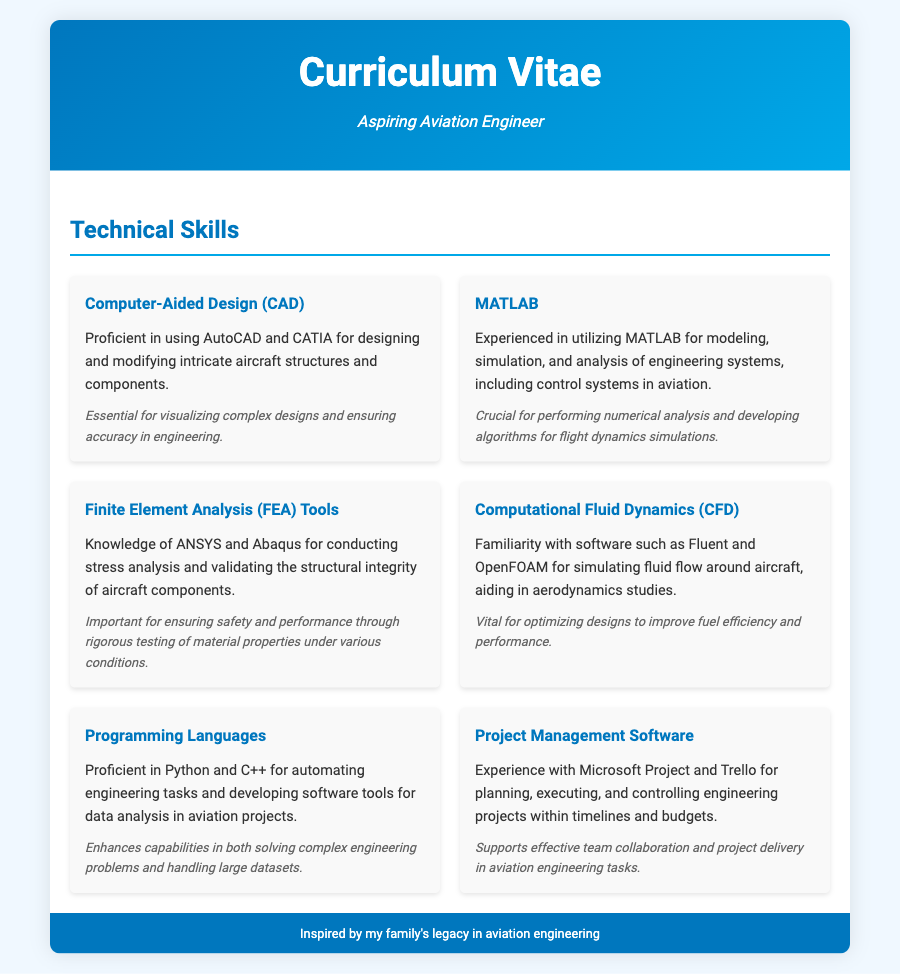What skill is used for designing aircraft structures? The skill related to designing aircraft structures is Computer-Aided Design (CAD).
Answer: Computer-Aided Design (CAD) Which software is mentioned for modeling and analysis in aviation? The software mentioned for modeling and analysis is MATLAB.
Answer: MATLAB What are the two programming languages mentioned? The programming languages listed in the document are Python and C++.
Answer: Python and C++ What tool is used for stress analysis of aircraft components? The tool mentioned for stress analysis is ANSYS or Abaqus.
Answer: ANSYS or Abaqus What is the relevance of MATLAB in aviation engineering? The relevance of MATLAB is performing numerical analysis and developing algorithms for flight dynamics simulations.
Answer: Performing numerical analysis and developing algorithms for flight dynamics simulations Which software is cited for planning engineering projects? The software used for planning engineering projects is Microsoft Project or Trello.
Answer: Microsoft Project or Trello How many CAD software tools are listed? Two CAD software tools are listed: AutoCAD and CATIA.
Answer: Two What type of analysis tools are mentioned for fluid dynamics simulations? The tools mentioned for fluid dynamics simulations are Fluent and OpenFOAM.
Answer: Fluent and OpenFOAM What is essential for ensuring accuracy in engineering? The essential skill for ensuring accuracy in engineering is Computer-Aided Design (CAD).
Answer: Computer-Aided Design (CAD) 